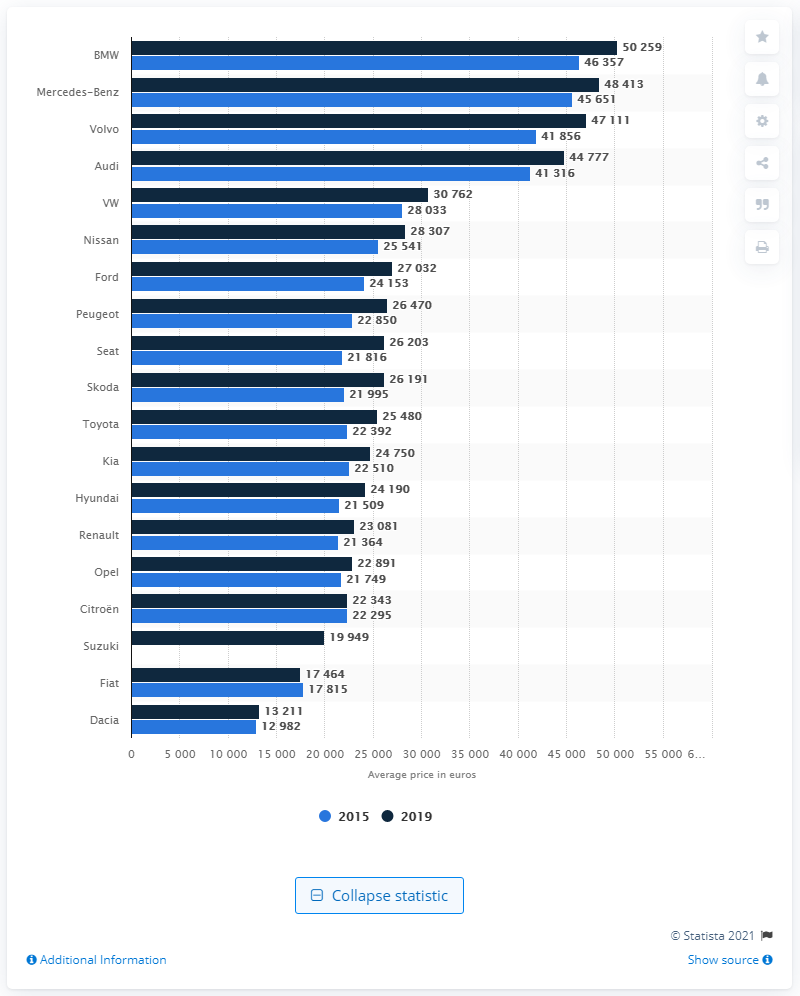Give some essential details in this illustration. According to the Mercedes-Benz, it was announced that the most expensive car in the European Union in the year 2019 was Mercedes-Benz. Fiat was the only automotive brand to experience a decrease in average sale price between 2015 and 2019. 